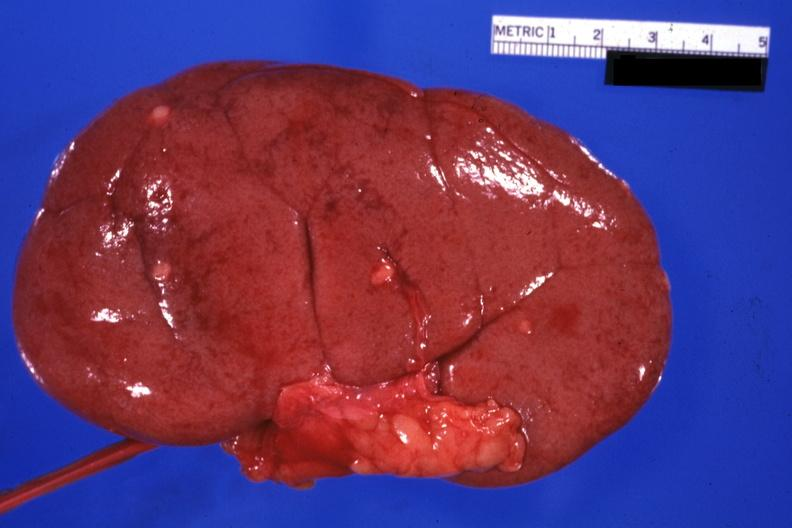s prostate removed small lesions easily seen?
Answer the question using a single word or phrase. No 